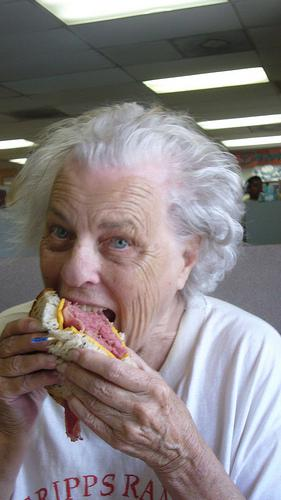Question: where is she eating?
Choices:
A. Inside a building.
B. In the kitchen.
C. At a cafe.
D. In her room.
Answer with the letter. Answer: A Question: why is she eating?
Choices:
A. Contest.
B. Pregnant.
C. Hungry.
D. Munchies.
Answer with the letter. Answer: C Question: what is she eating?
Choices:
A. Burger.
B. Pizza.
C. Tofu.
D. Sandwich.
Answer with the letter. Answer: D Question: why does she have wrinkles?
Choices:
A. Smoker.
B. Drinker.
C. Drugs.
D. Older.
Answer with the letter. Answer: D Question: what color are her eyes?
Choices:
A. Green.
B. Blue.
C. Black.
D. Hazel.
Answer with the letter. Answer: B 